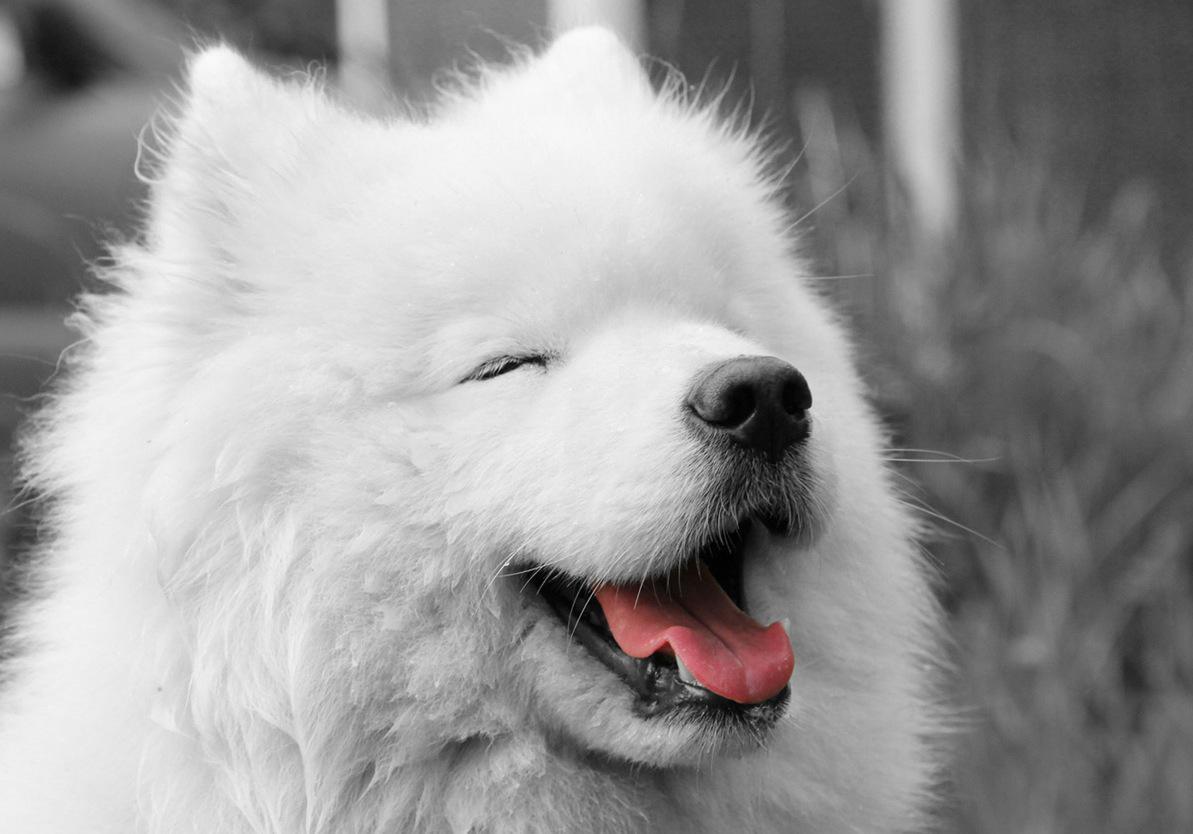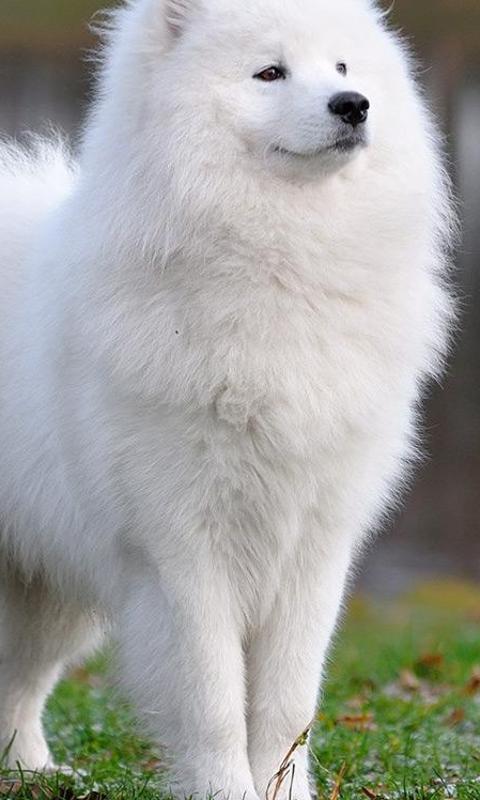The first image is the image on the left, the second image is the image on the right. Given the left and right images, does the statement "The right image contains a white dog facing towards the right." hold true? Answer yes or no. Yes. 